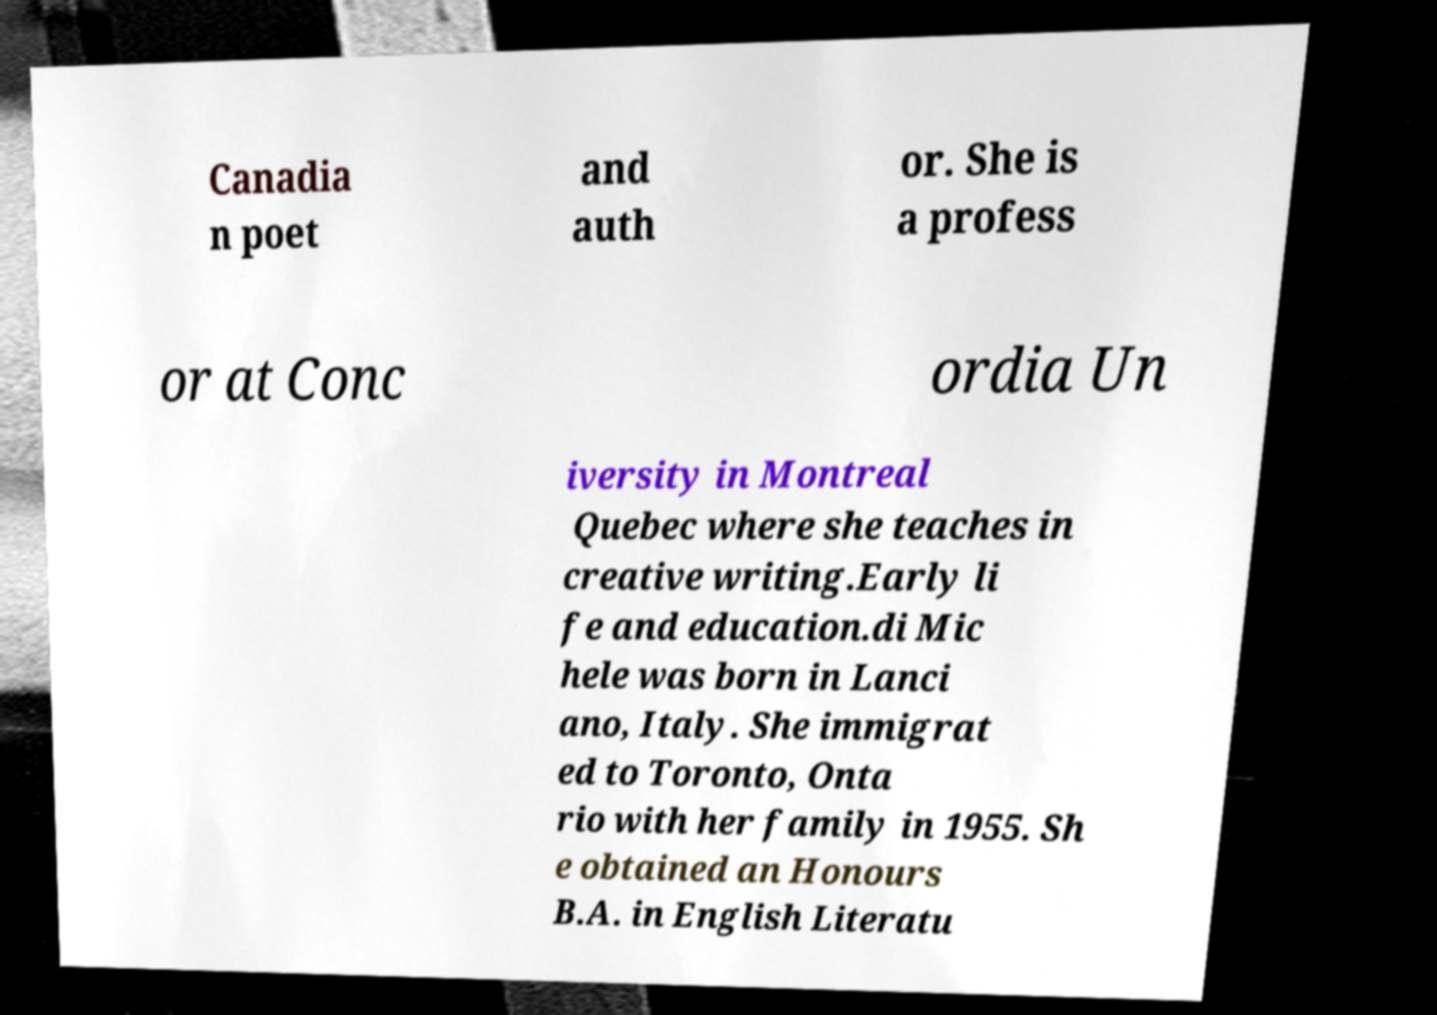Please read and relay the text visible in this image. What does it say? Canadia n poet and auth or. She is a profess or at Conc ordia Un iversity in Montreal Quebec where she teaches in creative writing.Early li fe and education.di Mic hele was born in Lanci ano, Italy. She immigrat ed to Toronto, Onta rio with her family in 1955. Sh e obtained an Honours B.A. in English Literatu 